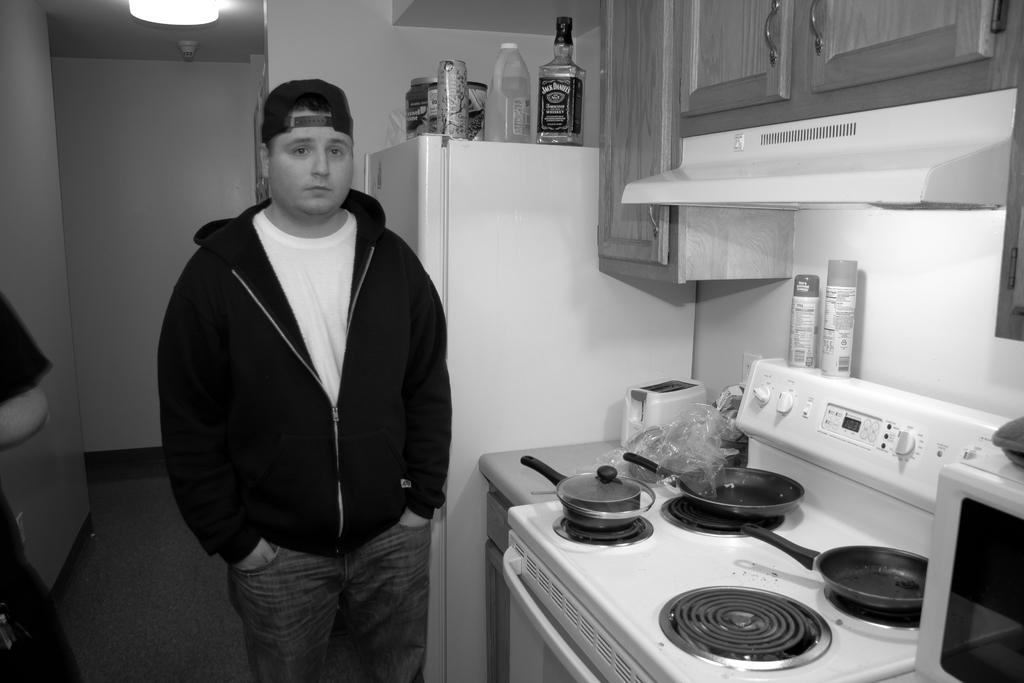What liquor bottle is on the fridge?
Keep it short and to the point. Jack daniels. 